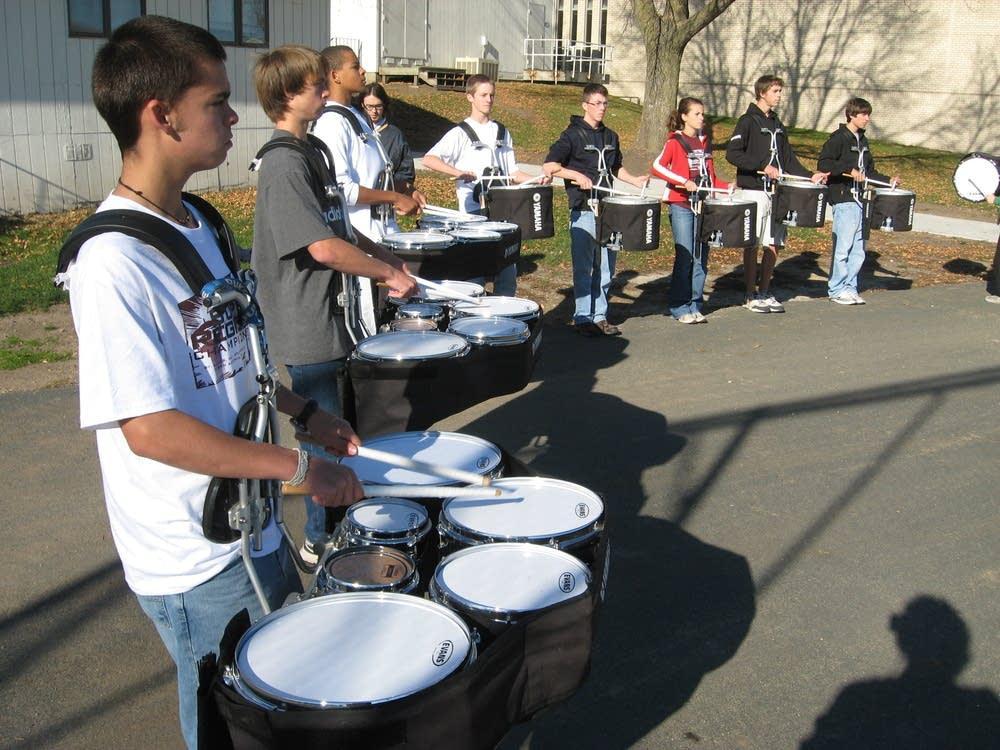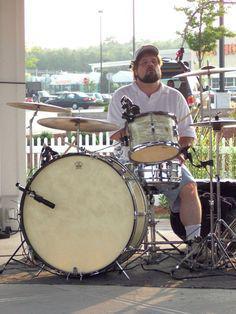The first image is the image on the left, the second image is the image on the right. For the images displayed, is the sentence "An image includes at least one person wearing a type of harness and standing behind a set of connected drums with four larger drums in front of two smaller ones." factually correct? Answer yes or no. Yes. The first image is the image on the left, the second image is the image on the right. Evaluate the accuracy of this statement regarding the images: "The image on the right shows a single person playing a drum kit with drumsticks.". Is it true? Answer yes or no. Yes. 